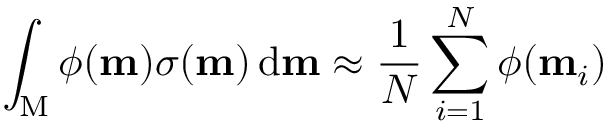<formula> <loc_0><loc_0><loc_500><loc_500>\int _ { M } \phi ( m ) \sigma ( m ) \, d m \approx \frac { 1 } { N } \sum _ { i = 1 } ^ { N } \phi ( m _ { i } )</formula> 